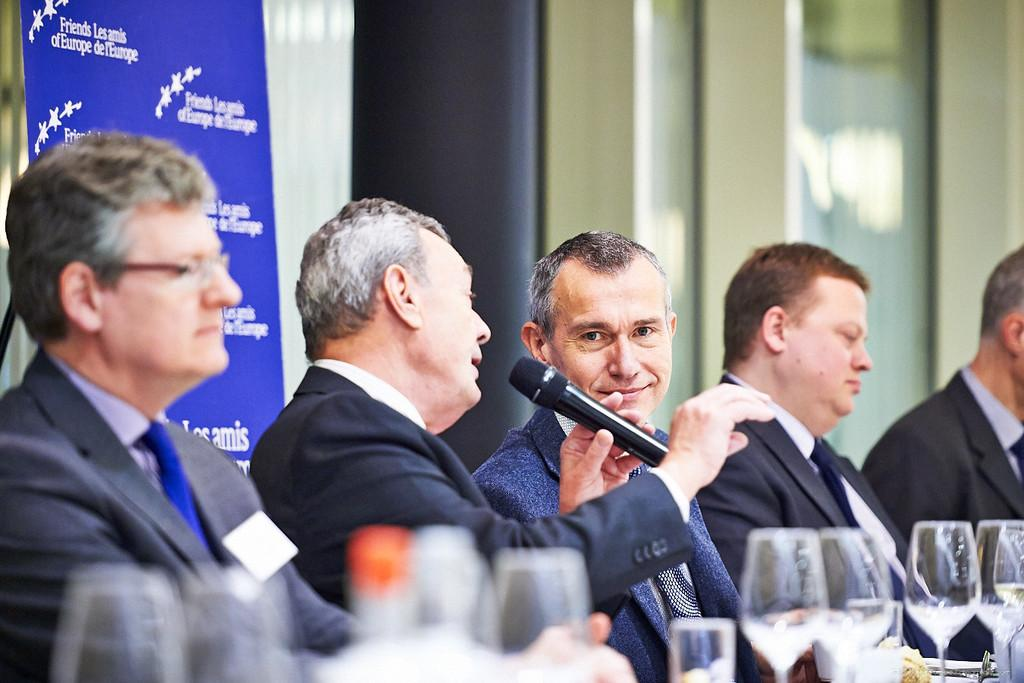How many men are in the image? There are men in the image, but the exact number is not specified. What is one of the men doing in the image? One man is holding a microphone in the image. What else can be seen in the image besides the men? There are glasses visible in the image. How does the man holding the microphone appear to be feeling? The man holding the microphone has a smile on his face, suggesting he is happy or enjoying himself. What is the value of the shelf in the image? There is no shelf present in the image, so it is not possible to determine its value. 